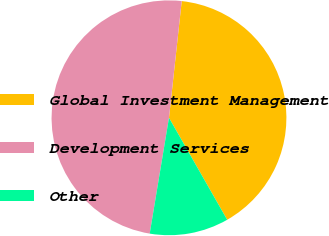Convert chart to OTSL. <chart><loc_0><loc_0><loc_500><loc_500><pie_chart><fcel>Global Investment Management<fcel>Development Services<fcel>Other<nl><fcel>40.02%<fcel>49.11%<fcel>10.88%<nl></chart> 